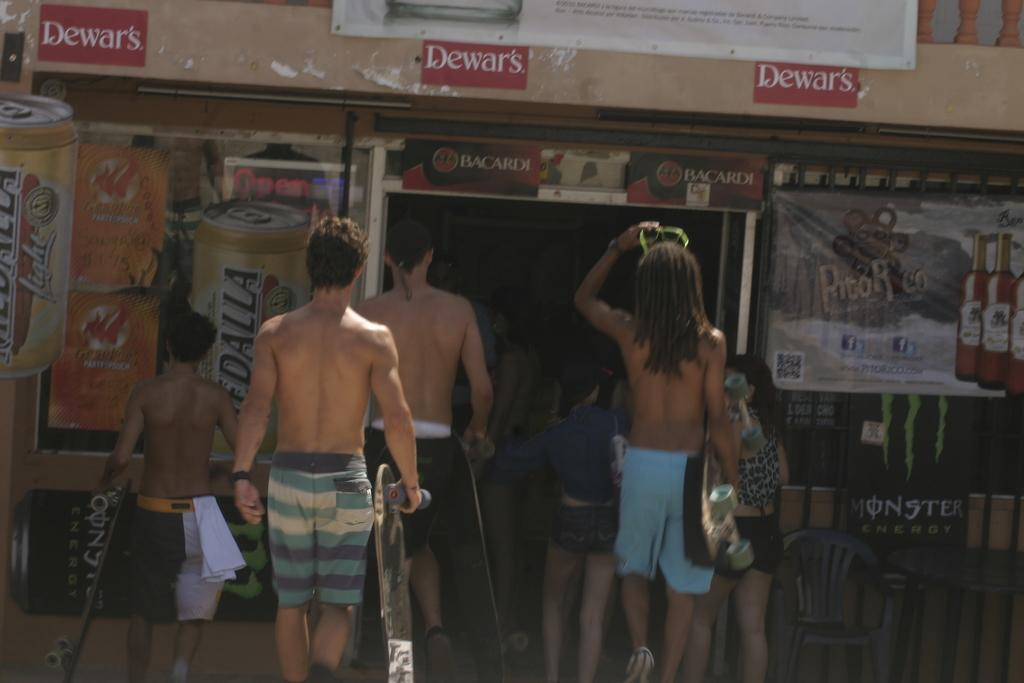What are the people in the image doing? The people in the image are walking. What type of clothing are the people wearing? The people are wearing shorts. Can you describe the setting of the image? The setting appears to be a bar. What can be seen on the left side of the image? There are beer tin pictures on the left side of the image. What is the tax rate for the beers in the image? There is no information about the tax rate for the beers in the image, as it does not mention any prices or taxes. Can you hear the thunder in the image? There is no mention of thunder or any sound in the image, so it cannot be heard. 